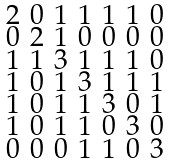<formula> <loc_0><loc_0><loc_500><loc_500>\begin{smallmatrix} 2 & 0 & 1 & 1 & 1 & 1 & 0 \\ 0 & 2 & 1 & 0 & 0 & 0 & 0 \\ 1 & 1 & 3 & 1 & 1 & 1 & 0 \\ 1 & 0 & 1 & 3 & 1 & 1 & 1 \\ 1 & 0 & 1 & 1 & 3 & 0 & 1 \\ 1 & 0 & 1 & 1 & 0 & 3 & 0 \\ 0 & 0 & 0 & 1 & 1 & 0 & 3 \end{smallmatrix}</formula> 